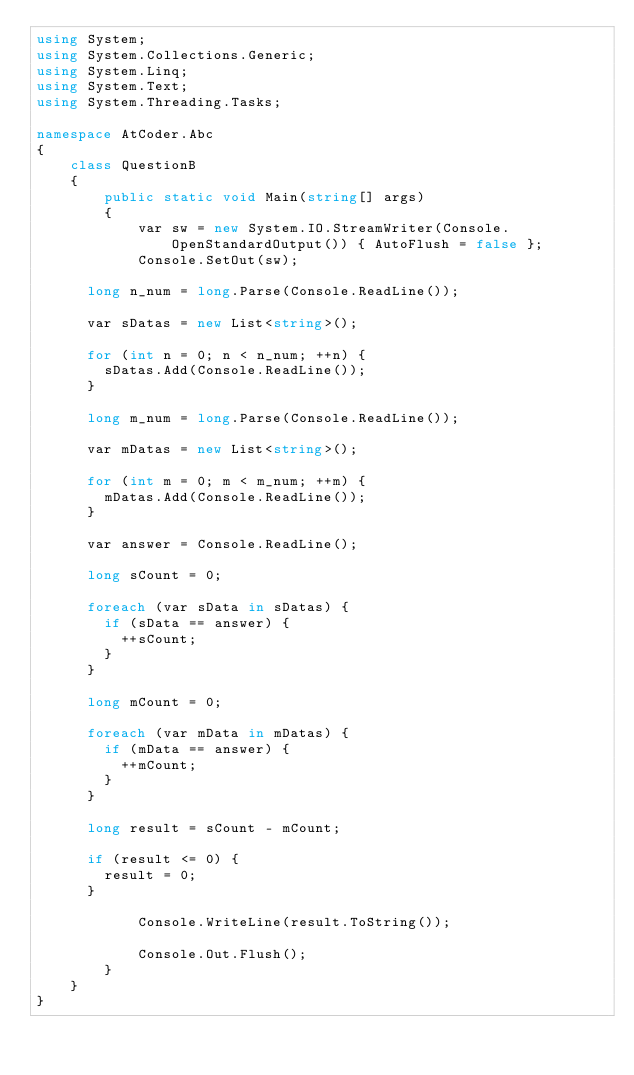Convert code to text. <code><loc_0><loc_0><loc_500><loc_500><_C#_>using System;
using System.Collections.Generic;
using System.Linq;
using System.Text;
using System.Threading.Tasks;

namespace AtCoder.Abc
{
    class QuestionB
    {
        public static void Main(string[] args)
        {
            var sw = new System.IO.StreamWriter(Console.OpenStandardOutput()) { AutoFlush = false };
            Console.SetOut(sw);

			long n_num = long.Parse(Console.ReadLine());

			var sDatas = new List<string>();

			for (int n = 0; n < n_num; ++n) {
				sDatas.Add(Console.ReadLine());
			}

			long m_num = long.Parse(Console.ReadLine());

			var mDatas = new List<string>();

			for (int m = 0; m < m_num; ++m) {
				mDatas.Add(Console.ReadLine());
			}

			var answer = Console.ReadLine();

			long sCount = 0;

			foreach (var sData in sDatas) {
				if (sData == answer) {
					++sCount;
				}
			}

			long mCount = 0;

			foreach (var mData in mDatas) {
				if (mData == answer) {
					++mCount;
				}
			}

			long result = sCount - mCount;

			if (result <= 0) {
				result = 0;
			}

            Console.WriteLine(result.ToString());

            Console.Out.Flush();
        }
    }
}
</code> 